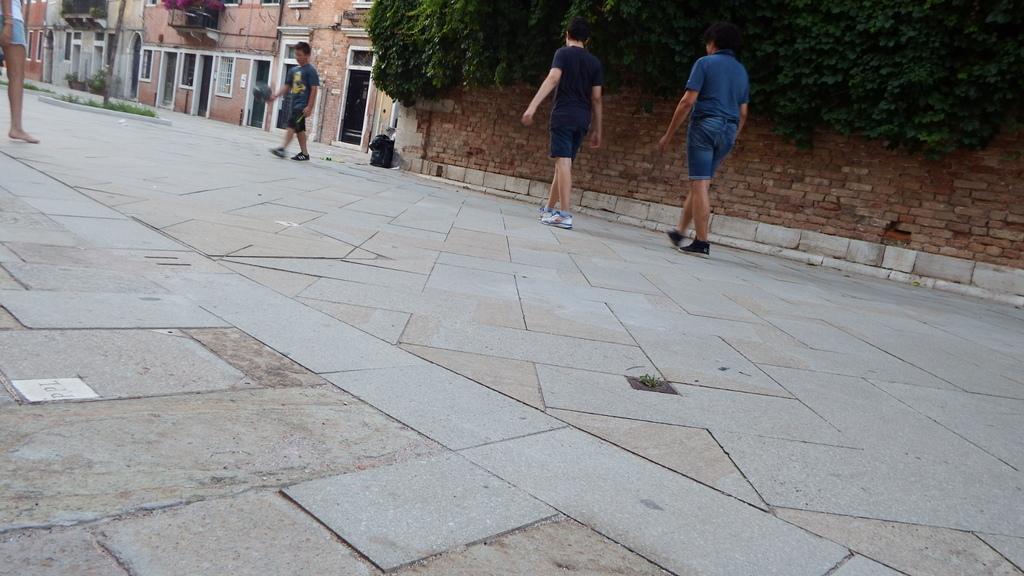Could you give a brief overview of what you see in this image? In this image we can see people walking on the road. In the background of the image there are buildings with doors and windows. To the right side of the image there is wall. There are leaves. 